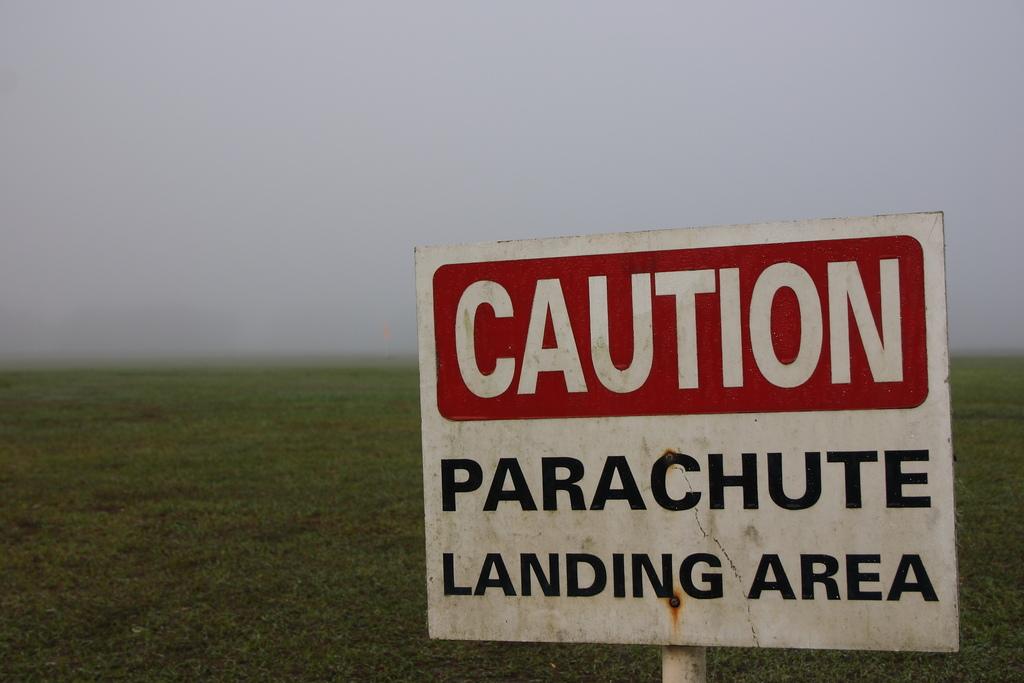Do we need to be careful about anything?
Offer a very short reply. Yes. 